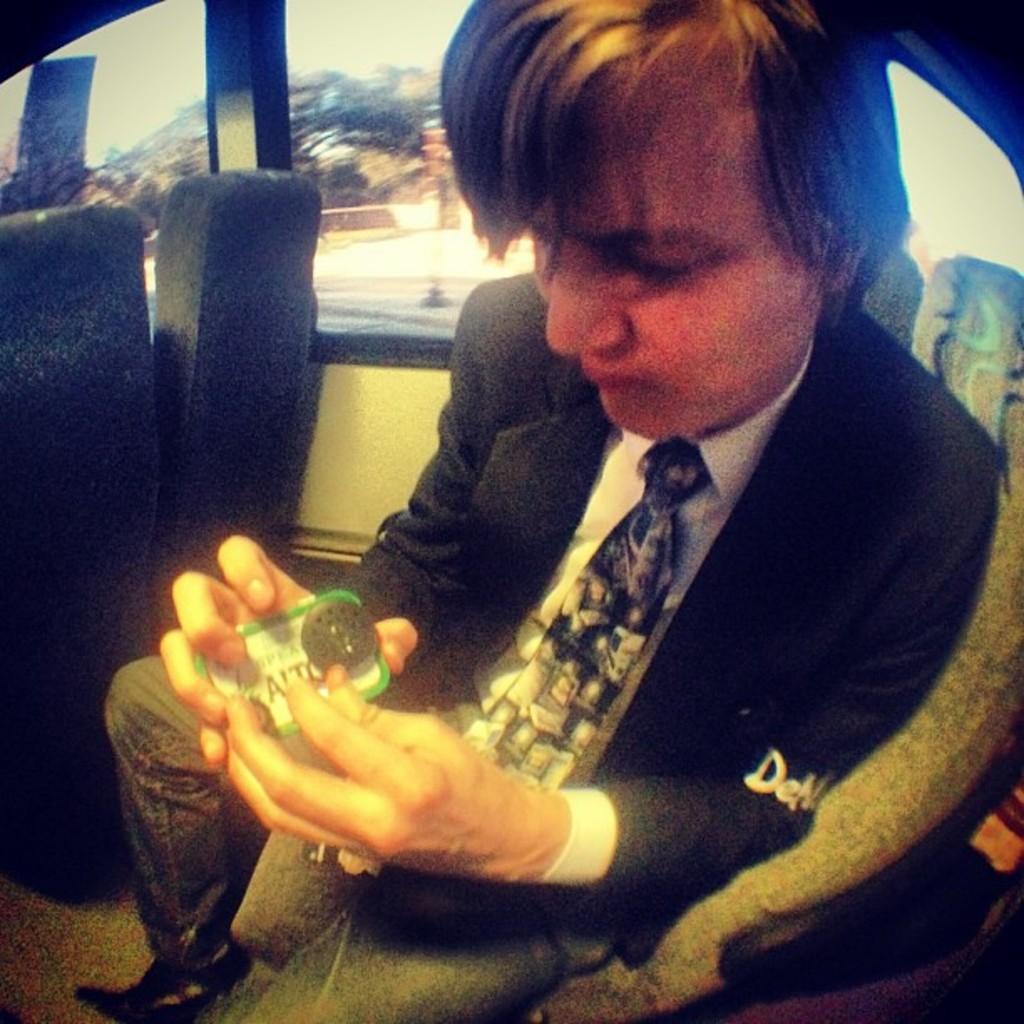Describe this image in one or two sentences. In this picture we can see a man wore blazer, tie and sitting on a seat inside a vehicle and he is holding an object with his hands. 